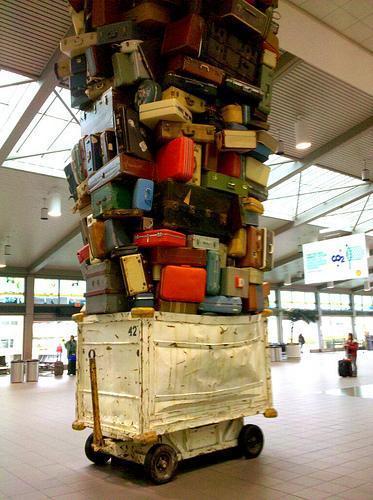How many tires can be seen?
Give a very brief answer. 3. How many suitcases are in the picture?
Give a very brief answer. 2. How many train tracks are there?
Give a very brief answer. 0. 